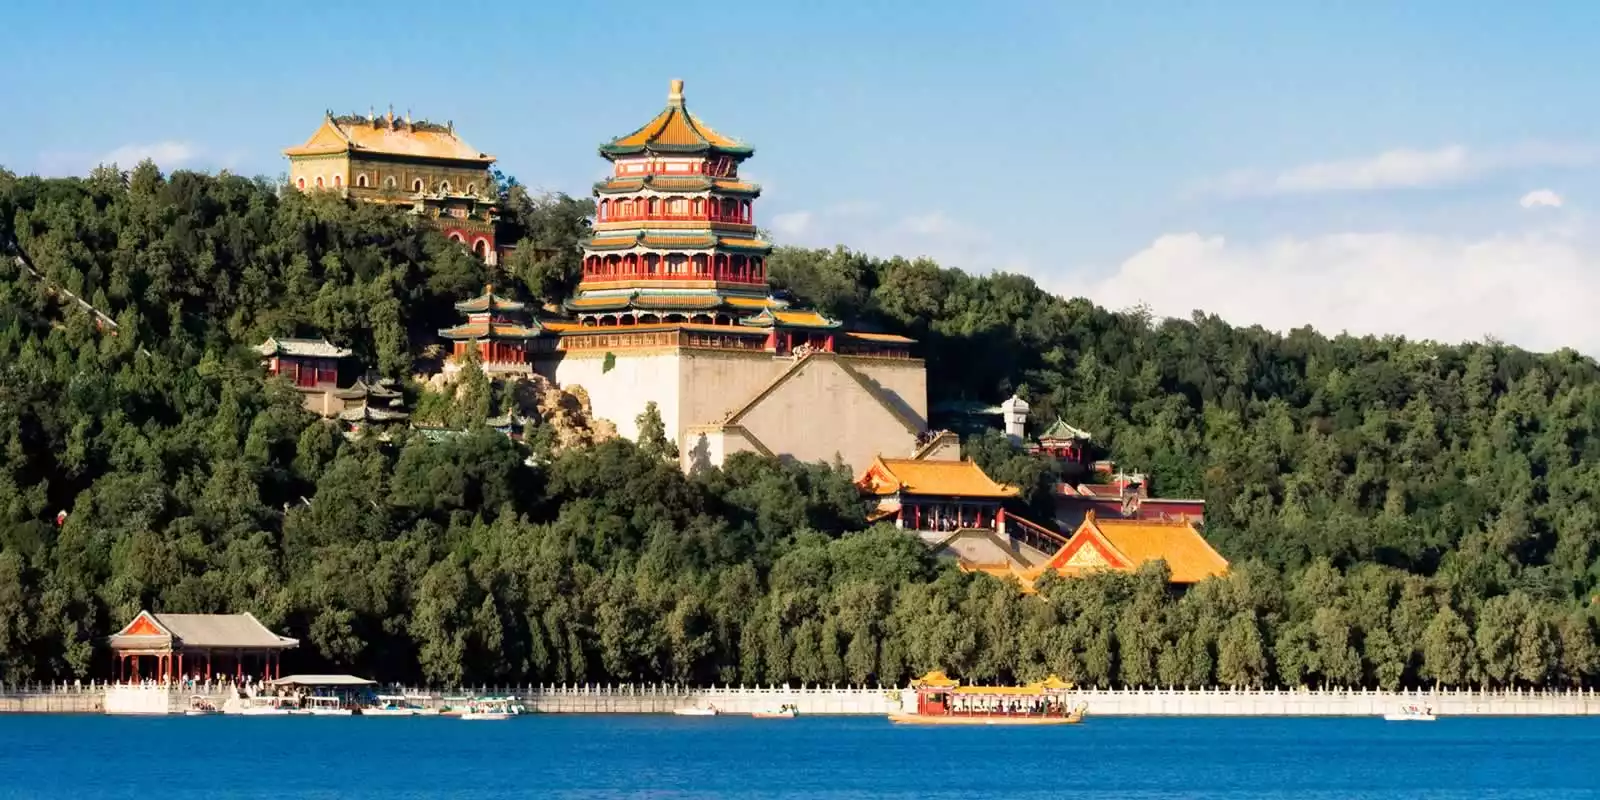Envision a fantastical tale that takes place within the walls of the Summer Palace. In a time long forgotten, the Summer Palace was not only the residence of the emperor but also a sanctuary for magical beings. Every evening, as the last rays of sunlight kissed the vibrant roofs of the palace, a hidden door would open in the Tower of Buddhist Incense. Through this door, a secret world would come to life—a world where dragons danced in the sky and phoenixes gilded the gardens with their fiery feathers. The emperor, a wise and benevolent ruler, had a pact with these mystical creatures. They shared their ancient wisdom and guarded the empire from unseen threats. One fateful night, a shadowy force threatened to consume the palace. The emperor, with the aid of the dragons' fire and the phoenixes' light, led a brave defense against the darkness. The night sky was ablaze with colors as magic clashed with the encroaching shadow. The emperor’s courage and the creatures' might eventually prevailed, sealing the darkness back into the netherworld. To this day, during quiet nights, some say the whispers of dragons and the soft glow of phoenixes can still be seen around the Summer Palace, reminding us of the fantastical saga that unfolded within its storied walls. 